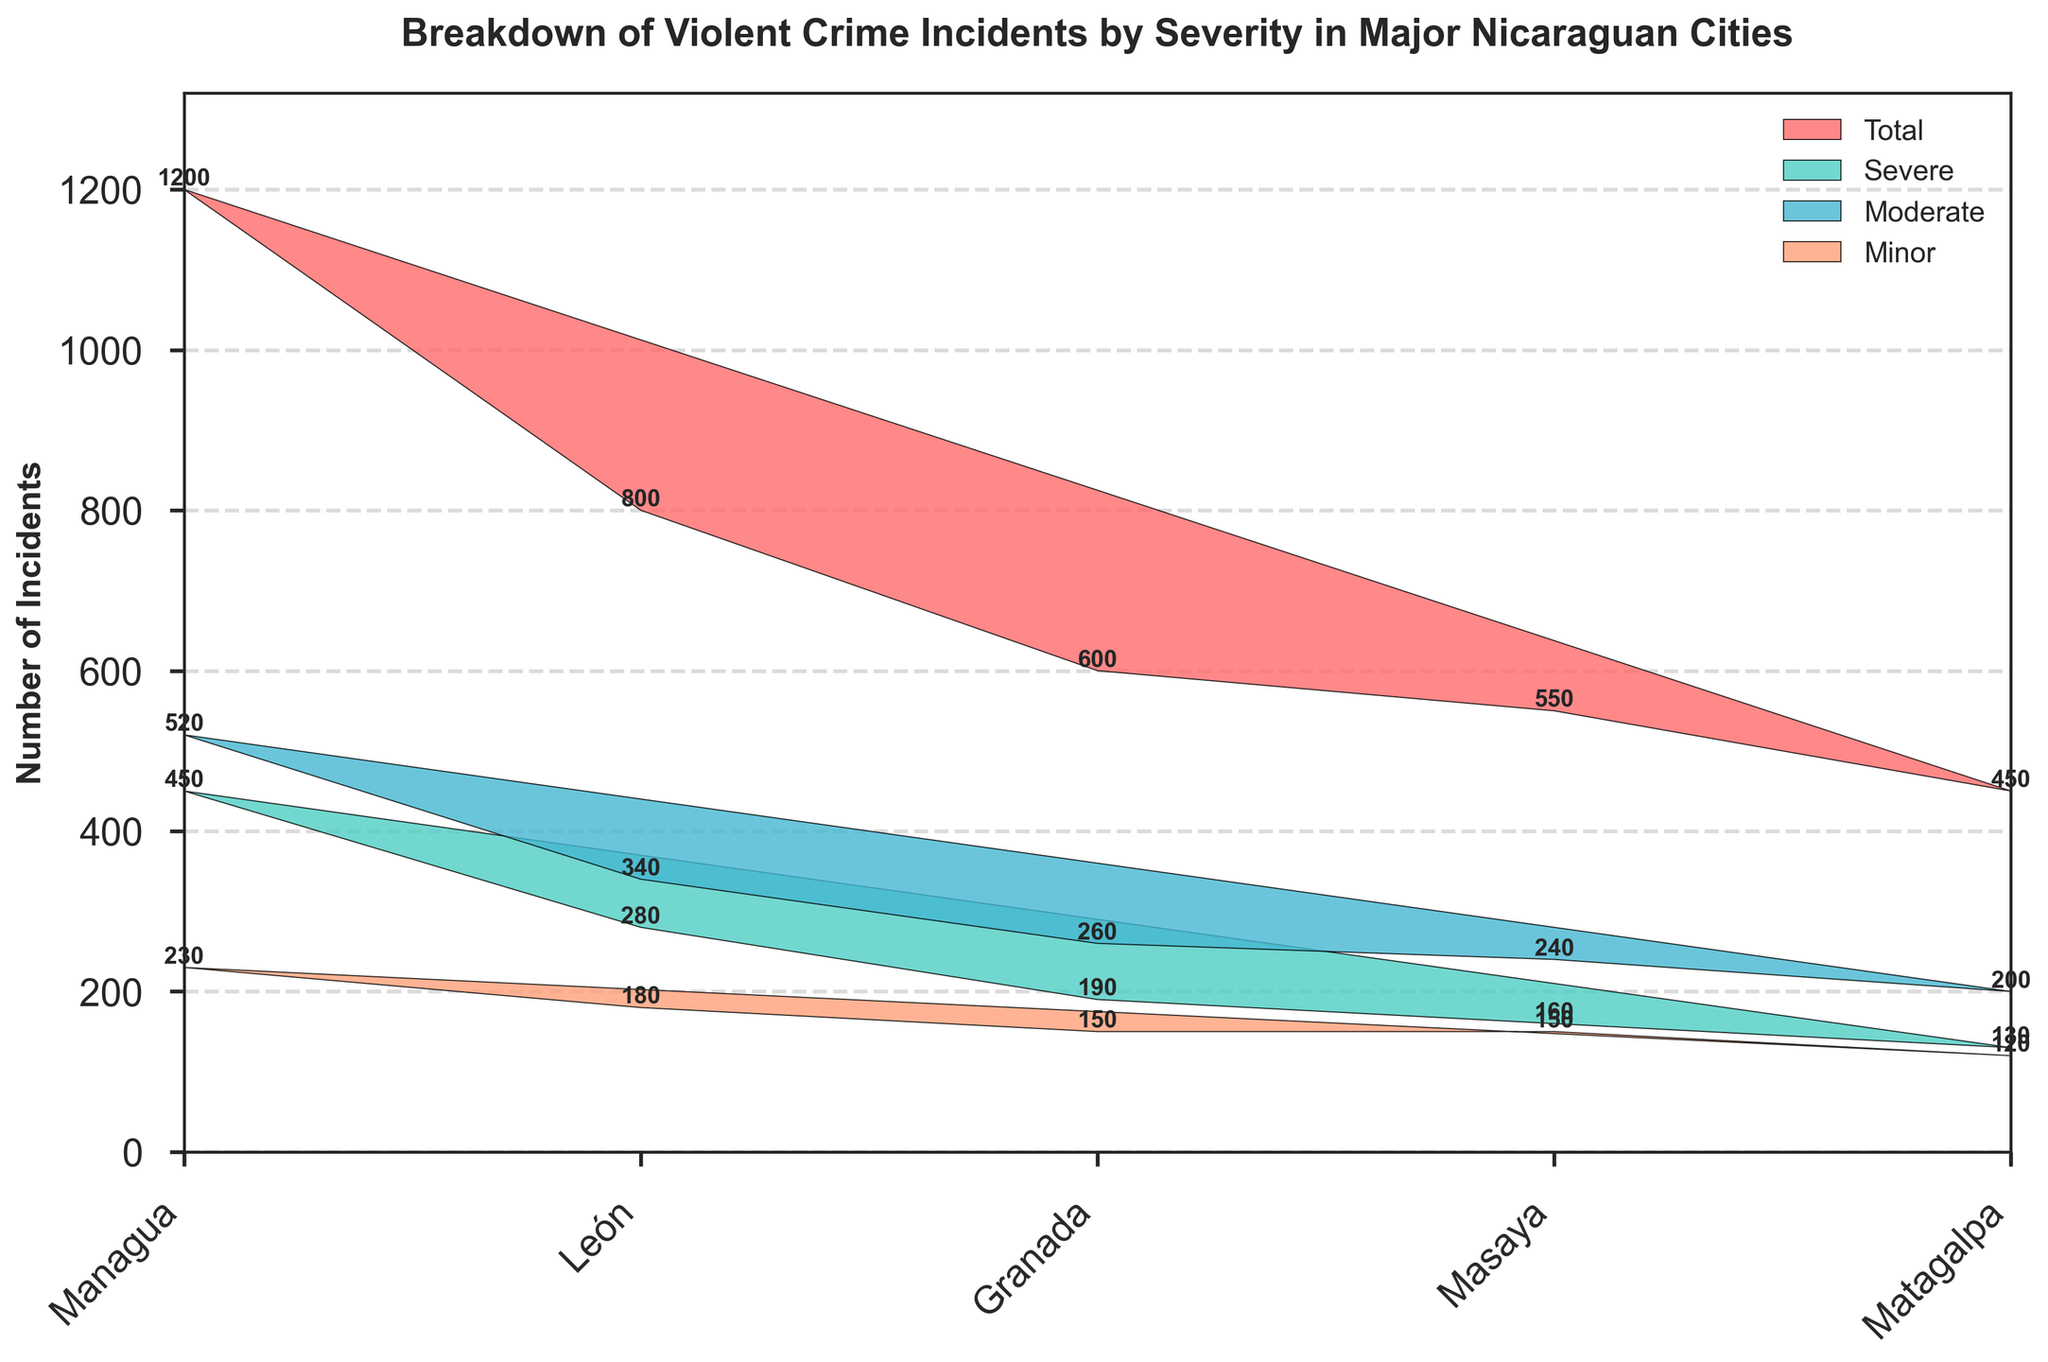What is the total number of violent crime incidents in Managua? The total number of incidents can be seen at the top of the bar for Managua in the plot.
Answer: 1200 Which city has the highest number of severe incidents? By comparing the "Severe" sections for each city, the city with the tallest bar segment in this category will be the one with the highest number.
Answer: Managua How many more moderate incidents are there in León compared to Matagalpa? Subtract the number of moderate incidents in Matagalpa from the number of moderate incidents in León (340 - 200).
Answer: 140 What's the difference between the total incidents in Granada and Masaya? Subtract the total incidents in Masaya from those in Granada (600 - 550).
Answer: 50 Which city has the lowest total number of incidents? By comparing the total heights of the bars representing "Total Incidents" for each city, the city with the shortest bar will be the one with the lowest number.
Answer: Matagalpa What is the sum of severe and moderate incidents in León? Add the number of severe and moderate incidents in León (280 + 340).
Answer: 620 Is the number of minor incidents in Granada greater than those in Masaya? Compare the heights of the "Minor" segments for Granada and Masaya.
Answer: No What percentage of total incidents in Managua are severe? Divide the number of severe incidents by the total incidents in Managua and multiply by 100 ((450 / 1200) * 100).
Answer: 37.5% Rank the cities from highest to lowest based on the total number of incidents. List the cities in descending order based on their "Total Incidents" values: Managua (1200), León (800), Granada (600), Masaya (550), Matagalpa (450).
Answer: Managua, León, Granada, Masaya, Matagalpa Which city has the smallest difference between severe and moderate incidents? Calculate the absolute differences between severe and moderate incidents for each city and identify the smallest: Managua (450 - 520), León (280 - 340), Granada (190 - 260), Masaya (160 - 240), Matagalpa (130 - 200).
Answer: Masaya 